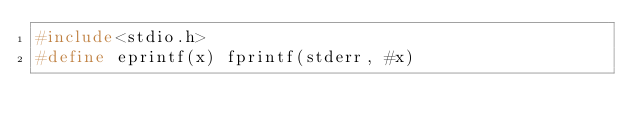Convert code to text. <code><loc_0><loc_0><loc_500><loc_500><_C_>#include<stdio.h>
#define eprintf(x) fprintf(stderr, #x)
</code> 